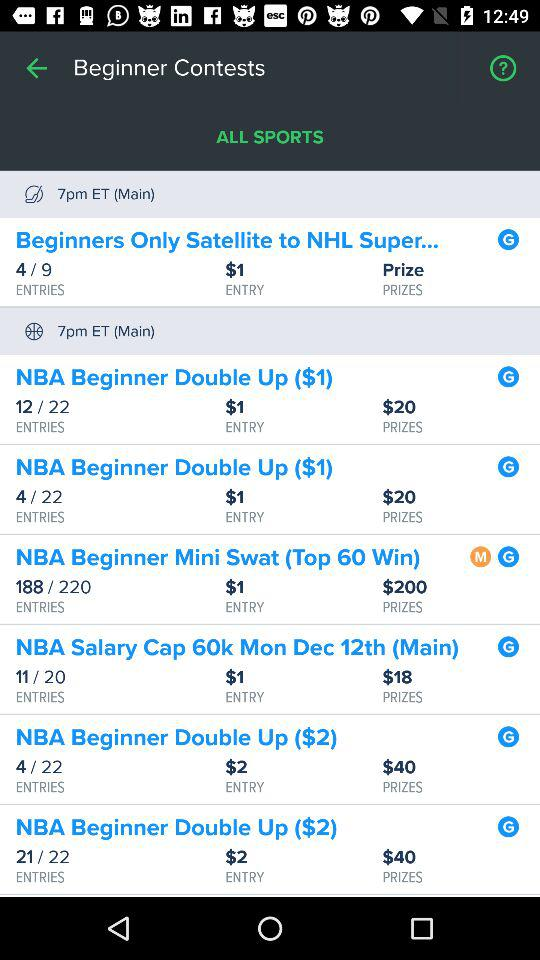Which contest has a price value of $18? The contest is "NBA Salary Cap 60k Mon Dec 12th (Main)". 